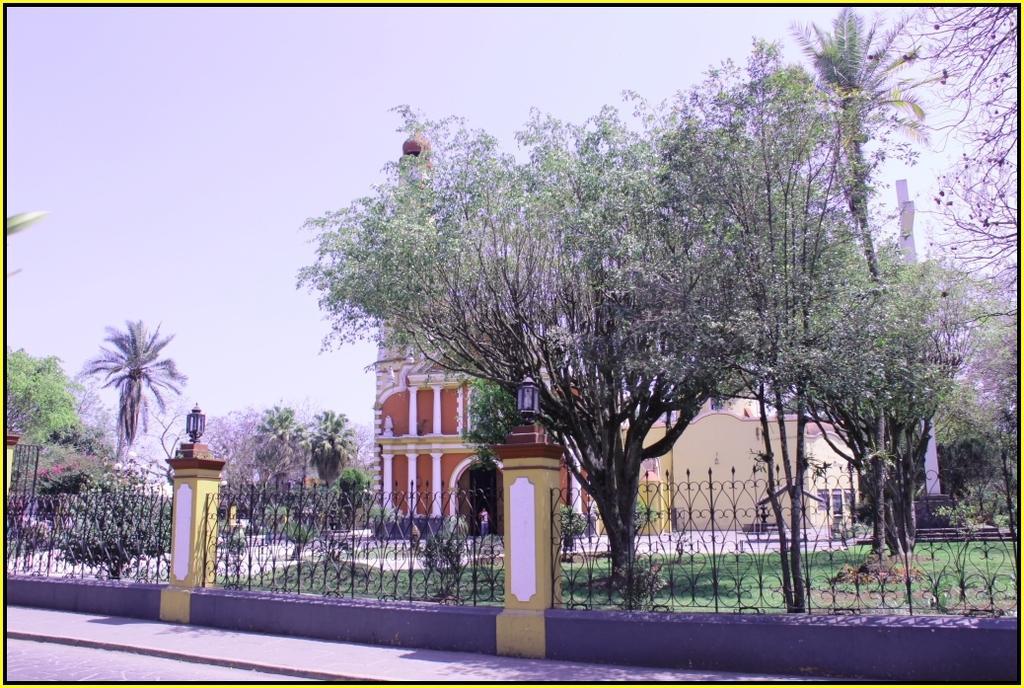Describe this image in one or two sentences. In the center of the image we can see tree and building. On the right side of the image we can see fencing, lights, cross, trees, grass. On the left side of the image we can see trees and plants. In the background we can see trees and sky. 